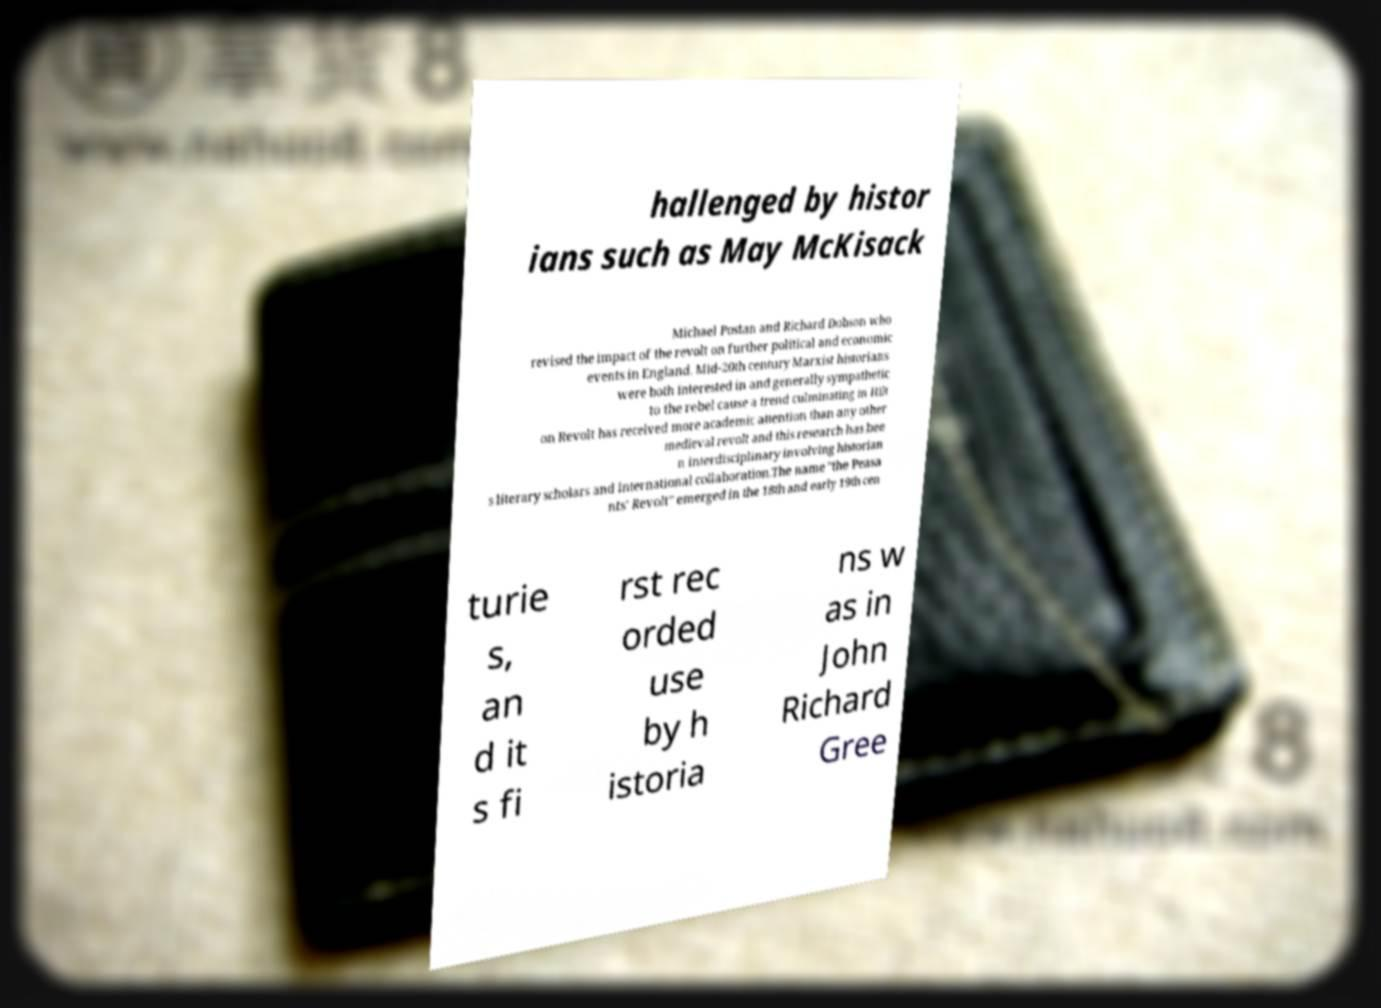Please read and relay the text visible in this image. What does it say? hallenged by histor ians such as May McKisack Michael Postan and Richard Dobson who revised the impact of the revolt on further political and economic events in England. Mid-20th century Marxist historians were both interested in and generally sympathetic to the rebel cause a trend culminating in Hilt on Revolt has received more academic attention than any other medieval revolt and this research has bee n interdisciplinary involving historian s literary scholars and international collaboration.The name "the Peasa nts' Revolt" emerged in the 18th and early 19th cen turie s, an d it s fi rst rec orded use by h istoria ns w as in John Richard Gree 